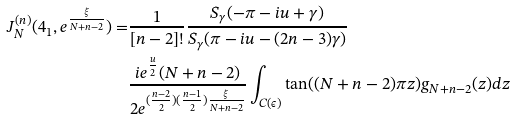<formula> <loc_0><loc_0><loc_500><loc_500>J _ { N } ^ { ( n ) } ( 4 _ { 1 } , e ^ { \frac { \xi } { N + n - 2 } } ) = & \frac { 1 } { [ n - 2 ] ! } \frac { S _ { \gamma } ( - \pi - i u + \gamma ) } { S _ { \gamma } ( \pi - i u - ( 2 n - 3 ) \gamma ) } \\ & \frac { i e ^ { \frac { u } { 2 } } ( N + n - 2 ) } { 2 e ^ { ( \frac { n - 2 } { 2 } ) ( \frac { n - 1 } { 2 } ) \frac { \xi } { N + n - 2 } } } \int _ { C ( \epsilon ) } \tan ( ( N + n - 2 ) \pi z ) g _ { N + n - 2 } ( z ) d z</formula> 